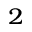Convert formula to latex. <formula><loc_0><loc_0><loc_500><loc_500>^ { 2 }</formula> 